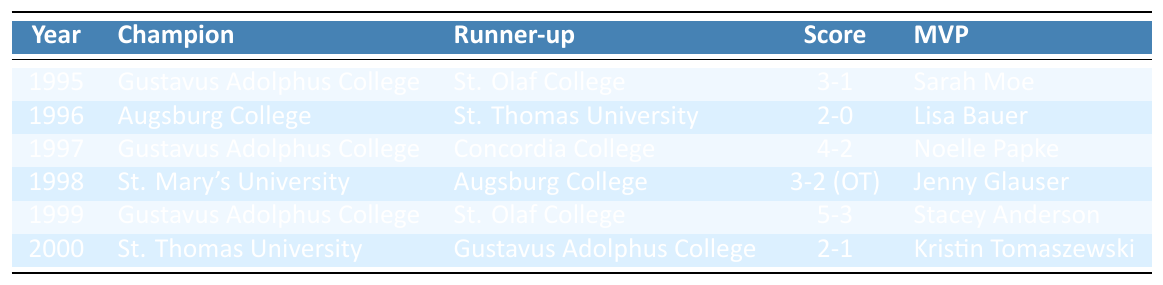What year did Gustavus Adolphus College win the championship? Gustavus Adolphus College won the championship in 1995, 1997, and 1999, as listed in the table under the Champion column for those respective years.
Answer: 1995, 1997, 1999 Who was the MVP in 1998? The MVP for 1998 is found in the row corresponding to that year in the MVP column, which indicates that Jenny Glauser received this honor.
Answer: Jenny Glauser What was the score in the 1996 championship game? The score for the 1996 championship game is stated directly in the table, listed as 2-0 beside the year 1996.
Answer: 2-0 How many championships did Augsburg College win in the years presented? By reviewing the Champion column, we can see that Augsburg College is mentioned as the champion only once in 1996, indicating they won one championship.
Answer: 1 Which team was the runner-up in 2000? The runner-up for the year 2000 can be found in the Runner-up column for that year, which identifies Gustavus Adolphus College as the team that placed second.
Answer: Gustavus Adolphus College Was there a championship that went into overtime? Looking through the Score column, the entry for 1998 shows a score of 3-2 (OT), indicating that this championship did go into overtime.
Answer: Yes What was the total number of championships won by Gustavus Adolphus College from 1995 to 2000? Evaluating the table, Gustavus Adolphus College won championships in 1995, 1997, and 1999, which totals three championships.
Answer: 3 Which year had the closest score in the championship game? By comparing the scores listed, the 1998 game had the closest score of 3-2 (OT), as it was only a one-point difference.
Answer: 1998 Who won the most championships in this period? From the Champion column, Gustavus Adolphus College appears three times as the champion, more than any other team.
Answer: Gustavus Adolphus College Did St. Thomas University ever lose the championship? In the table, St. Thomas University is listed as the champion in 2000, but they were the runner-up in 1996, which confirms they lost one championship.
Answer: Yes 